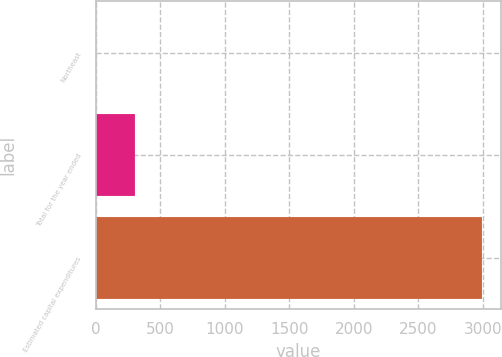Convert chart. <chart><loc_0><loc_0><loc_500><loc_500><bar_chart><fcel>Northeast<fcel>Total for the year ended<fcel>Estimated capital expenditures<nl><fcel>1<fcel>300.4<fcel>2995<nl></chart> 